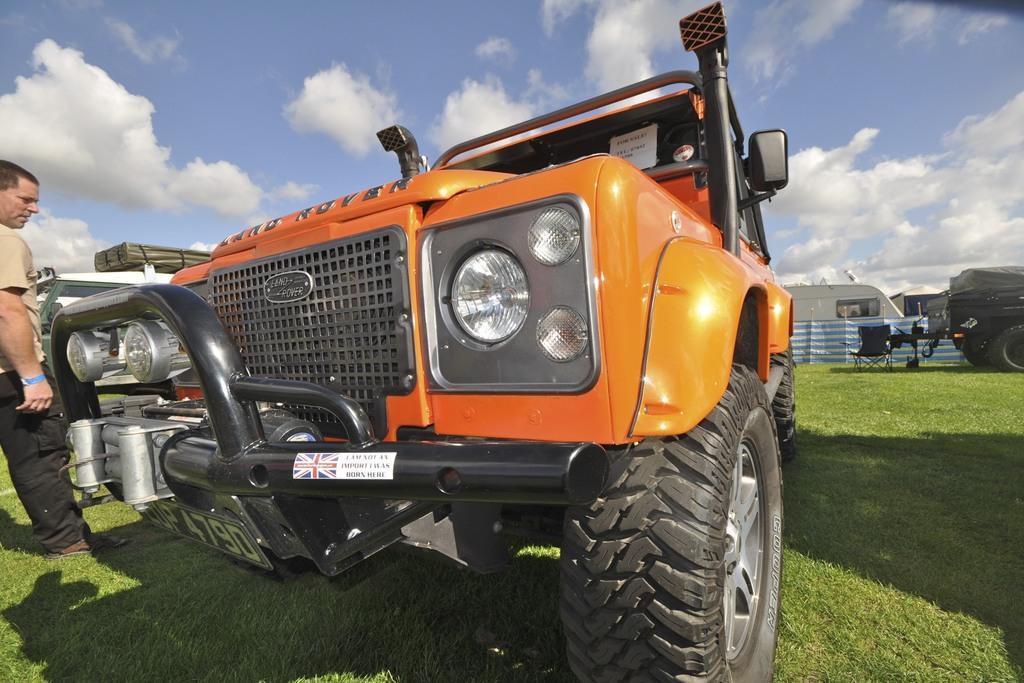Describe this image in one or two sentences. In this image there is the sky, there are clouds in the sky, towards the right of the image there is a vehicle truncated, there is a chair on the ground, there is grass, there are vehicles, towards the left of the image there is a person truncated. 